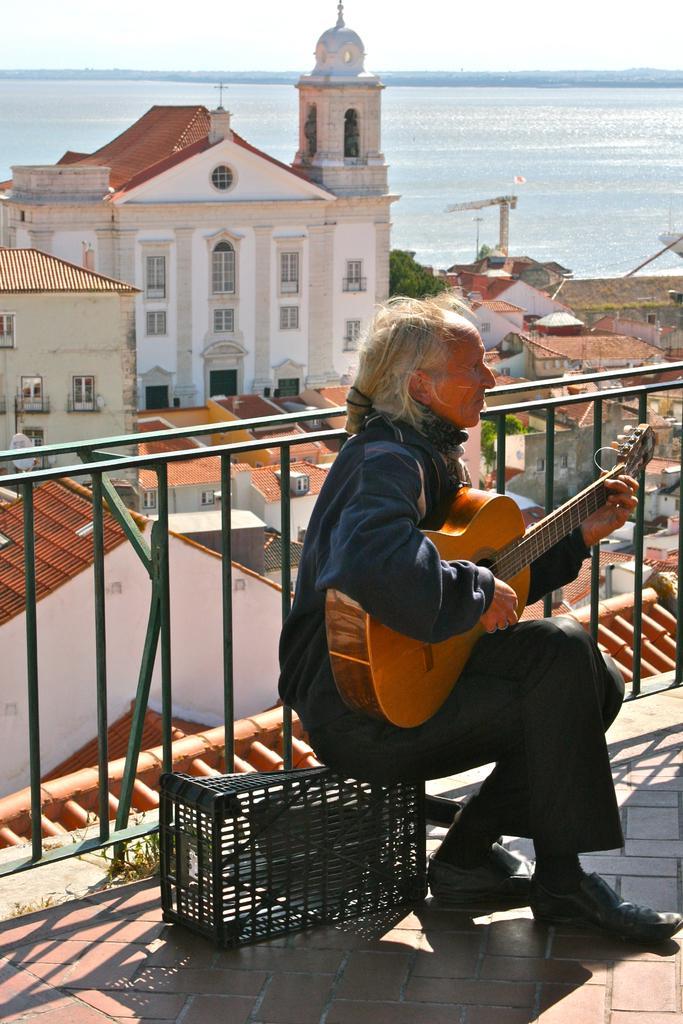In one or two sentences, can you explain what this image depicts? this picture shows a man seated and playing a guitar and we see few houses around and we see a ocean 